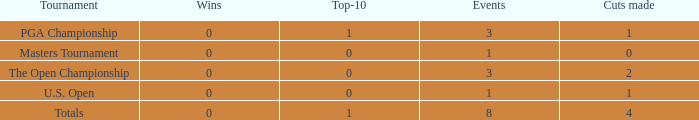For events with under 3 times played and fewer than 1 cut made, what is the total number of top-10 finishes? 1.0. 